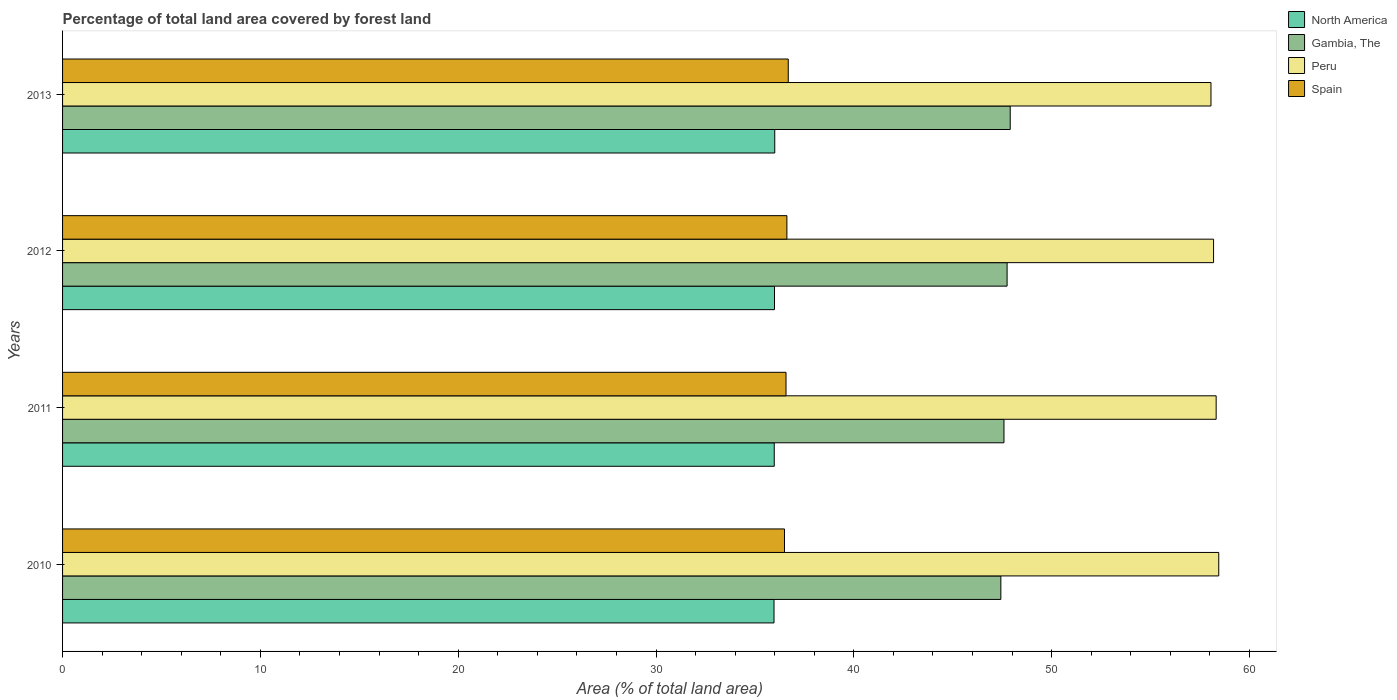Are the number of bars on each tick of the Y-axis equal?
Make the answer very short. Yes. How many bars are there on the 1st tick from the top?
Keep it short and to the point. 4. How many bars are there on the 4th tick from the bottom?
Offer a very short reply. 4. What is the percentage of forest land in Peru in 2011?
Keep it short and to the point. 58.32. Across all years, what is the maximum percentage of forest land in Spain?
Provide a succinct answer. 36.68. Across all years, what is the minimum percentage of forest land in North America?
Keep it short and to the point. 35.96. In which year was the percentage of forest land in Spain maximum?
Offer a very short reply. 2013. In which year was the percentage of forest land in Spain minimum?
Your answer should be compact. 2010. What is the total percentage of forest land in Peru in the graph?
Offer a terse response. 233. What is the difference between the percentage of forest land in Spain in 2010 and that in 2012?
Offer a very short reply. -0.12. What is the difference between the percentage of forest land in Gambia, The in 2013 and the percentage of forest land in North America in 2012?
Provide a succinct answer. 11.92. What is the average percentage of forest land in Spain per year?
Your answer should be very brief. 36.59. In the year 2012, what is the difference between the percentage of forest land in Peru and percentage of forest land in Spain?
Offer a terse response. 21.57. What is the ratio of the percentage of forest land in North America in 2010 to that in 2011?
Give a very brief answer. 1. Is the percentage of forest land in Spain in 2011 less than that in 2012?
Provide a succinct answer. Yes. Is the difference between the percentage of forest land in Peru in 2010 and 2013 greater than the difference between the percentage of forest land in Spain in 2010 and 2013?
Offer a terse response. Yes. What is the difference between the highest and the second highest percentage of forest land in Spain?
Provide a succinct answer. 0.07. What is the difference between the highest and the lowest percentage of forest land in Spain?
Keep it short and to the point. 0.19. What does the 3rd bar from the top in 2010 represents?
Your answer should be compact. Gambia, The. Are all the bars in the graph horizontal?
Your answer should be very brief. Yes. How many years are there in the graph?
Your response must be concise. 4. What is the difference between two consecutive major ticks on the X-axis?
Provide a short and direct response. 10. Does the graph contain any zero values?
Provide a short and direct response. No. Does the graph contain grids?
Keep it short and to the point. No. How are the legend labels stacked?
Offer a very short reply. Vertical. What is the title of the graph?
Your response must be concise. Percentage of total land area covered by forest land. What is the label or title of the X-axis?
Your answer should be compact. Area (% of total land area). What is the label or title of the Y-axis?
Make the answer very short. Years. What is the Area (% of total land area) of North America in 2010?
Give a very brief answer. 35.96. What is the Area (% of total land area) of Gambia, The in 2010?
Your answer should be compact. 47.43. What is the Area (% of total land area) of Peru in 2010?
Your answer should be very brief. 58.45. What is the Area (% of total land area) in Spain in 2010?
Give a very brief answer. 36.49. What is the Area (% of total land area) in North America in 2011?
Your answer should be compact. 35.98. What is the Area (% of total land area) in Gambia, The in 2011?
Make the answer very short. 47.59. What is the Area (% of total land area) of Peru in 2011?
Offer a very short reply. 58.32. What is the Area (% of total land area) in Spain in 2011?
Your answer should be very brief. 36.57. What is the Area (% of total land area) in North America in 2012?
Keep it short and to the point. 35.99. What is the Area (% of total land area) in Gambia, The in 2012?
Give a very brief answer. 47.75. What is the Area (% of total land area) in Peru in 2012?
Offer a very short reply. 58.18. What is the Area (% of total land area) in Spain in 2012?
Keep it short and to the point. 36.62. What is the Area (% of total land area) in North America in 2013?
Your response must be concise. 36. What is the Area (% of total land area) of Gambia, The in 2013?
Make the answer very short. 47.91. What is the Area (% of total land area) of Peru in 2013?
Provide a short and direct response. 58.05. What is the Area (% of total land area) in Spain in 2013?
Provide a short and direct response. 36.68. Across all years, what is the maximum Area (% of total land area) in North America?
Provide a succinct answer. 36. Across all years, what is the maximum Area (% of total land area) of Gambia, The?
Offer a very short reply. 47.91. Across all years, what is the maximum Area (% of total land area) of Peru?
Your response must be concise. 58.45. Across all years, what is the maximum Area (% of total land area) of Spain?
Your answer should be compact. 36.68. Across all years, what is the minimum Area (% of total land area) of North America?
Make the answer very short. 35.96. Across all years, what is the minimum Area (% of total land area) of Gambia, The?
Ensure brevity in your answer.  47.43. Across all years, what is the minimum Area (% of total land area) in Peru?
Your response must be concise. 58.05. Across all years, what is the minimum Area (% of total land area) in Spain?
Provide a succinct answer. 36.49. What is the total Area (% of total land area) in North America in the graph?
Make the answer very short. 143.93. What is the total Area (% of total land area) in Gambia, The in the graph?
Give a very brief answer. 190.67. What is the total Area (% of total land area) of Peru in the graph?
Provide a succinct answer. 233. What is the total Area (% of total land area) in Spain in the graph?
Keep it short and to the point. 146.36. What is the difference between the Area (% of total land area) of North America in 2010 and that in 2011?
Provide a succinct answer. -0.01. What is the difference between the Area (% of total land area) of Gambia, The in 2010 and that in 2011?
Your answer should be compact. -0.16. What is the difference between the Area (% of total land area) of Peru in 2010 and that in 2011?
Your answer should be compact. 0.13. What is the difference between the Area (% of total land area) in Spain in 2010 and that in 2011?
Your response must be concise. -0.08. What is the difference between the Area (% of total land area) in North America in 2010 and that in 2012?
Your answer should be very brief. -0.03. What is the difference between the Area (% of total land area) of Gambia, The in 2010 and that in 2012?
Offer a very short reply. -0.32. What is the difference between the Area (% of total land area) in Peru in 2010 and that in 2012?
Give a very brief answer. 0.26. What is the difference between the Area (% of total land area) in Spain in 2010 and that in 2012?
Your response must be concise. -0.12. What is the difference between the Area (% of total land area) in North America in 2010 and that in 2013?
Offer a terse response. -0.04. What is the difference between the Area (% of total land area) of Gambia, The in 2010 and that in 2013?
Your response must be concise. -0.47. What is the difference between the Area (% of total land area) of Peru in 2010 and that in 2013?
Your answer should be compact. 0.39. What is the difference between the Area (% of total land area) in Spain in 2010 and that in 2013?
Your response must be concise. -0.19. What is the difference between the Area (% of total land area) in North America in 2011 and that in 2012?
Provide a short and direct response. -0.01. What is the difference between the Area (% of total land area) in Gambia, The in 2011 and that in 2012?
Keep it short and to the point. -0.16. What is the difference between the Area (% of total land area) in Peru in 2011 and that in 2012?
Keep it short and to the point. 0.13. What is the difference between the Area (% of total land area) of Spain in 2011 and that in 2012?
Provide a short and direct response. -0.04. What is the difference between the Area (% of total land area) of North America in 2011 and that in 2013?
Make the answer very short. -0.03. What is the difference between the Area (% of total land area) of Gambia, The in 2011 and that in 2013?
Offer a very short reply. -0.32. What is the difference between the Area (% of total land area) of Peru in 2011 and that in 2013?
Offer a terse response. 0.26. What is the difference between the Area (% of total land area) in Spain in 2011 and that in 2013?
Offer a very short reply. -0.11. What is the difference between the Area (% of total land area) in North America in 2012 and that in 2013?
Give a very brief answer. -0.01. What is the difference between the Area (% of total land area) of Gambia, The in 2012 and that in 2013?
Provide a short and direct response. -0.16. What is the difference between the Area (% of total land area) in Peru in 2012 and that in 2013?
Give a very brief answer. 0.13. What is the difference between the Area (% of total land area) of Spain in 2012 and that in 2013?
Your response must be concise. -0.07. What is the difference between the Area (% of total land area) in North America in 2010 and the Area (% of total land area) in Gambia, The in 2011?
Your answer should be compact. -11.62. What is the difference between the Area (% of total land area) in North America in 2010 and the Area (% of total land area) in Peru in 2011?
Give a very brief answer. -22.35. What is the difference between the Area (% of total land area) in North America in 2010 and the Area (% of total land area) in Spain in 2011?
Give a very brief answer. -0.61. What is the difference between the Area (% of total land area) of Gambia, The in 2010 and the Area (% of total land area) of Peru in 2011?
Ensure brevity in your answer.  -10.88. What is the difference between the Area (% of total land area) in Gambia, The in 2010 and the Area (% of total land area) in Spain in 2011?
Offer a terse response. 10.86. What is the difference between the Area (% of total land area) of Peru in 2010 and the Area (% of total land area) of Spain in 2011?
Keep it short and to the point. 21.87. What is the difference between the Area (% of total land area) of North America in 2010 and the Area (% of total land area) of Gambia, The in 2012?
Your answer should be compact. -11.78. What is the difference between the Area (% of total land area) of North America in 2010 and the Area (% of total land area) of Peru in 2012?
Give a very brief answer. -22.22. What is the difference between the Area (% of total land area) of North America in 2010 and the Area (% of total land area) of Spain in 2012?
Keep it short and to the point. -0.65. What is the difference between the Area (% of total land area) in Gambia, The in 2010 and the Area (% of total land area) in Peru in 2012?
Provide a succinct answer. -10.75. What is the difference between the Area (% of total land area) in Gambia, The in 2010 and the Area (% of total land area) in Spain in 2012?
Provide a succinct answer. 10.82. What is the difference between the Area (% of total land area) in Peru in 2010 and the Area (% of total land area) in Spain in 2012?
Give a very brief answer. 21.83. What is the difference between the Area (% of total land area) in North America in 2010 and the Area (% of total land area) in Gambia, The in 2013?
Offer a terse response. -11.94. What is the difference between the Area (% of total land area) of North America in 2010 and the Area (% of total land area) of Peru in 2013?
Your response must be concise. -22.09. What is the difference between the Area (% of total land area) in North America in 2010 and the Area (% of total land area) in Spain in 2013?
Make the answer very short. -0.72. What is the difference between the Area (% of total land area) of Gambia, The in 2010 and the Area (% of total land area) of Peru in 2013?
Keep it short and to the point. -10.62. What is the difference between the Area (% of total land area) in Gambia, The in 2010 and the Area (% of total land area) in Spain in 2013?
Make the answer very short. 10.75. What is the difference between the Area (% of total land area) of Peru in 2010 and the Area (% of total land area) of Spain in 2013?
Give a very brief answer. 21.76. What is the difference between the Area (% of total land area) of North America in 2011 and the Area (% of total land area) of Gambia, The in 2012?
Provide a short and direct response. -11.77. What is the difference between the Area (% of total land area) of North America in 2011 and the Area (% of total land area) of Peru in 2012?
Offer a terse response. -22.21. What is the difference between the Area (% of total land area) in North America in 2011 and the Area (% of total land area) in Spain in 2012?
Provide a succinct answer. -0.64. What is the difference between the Area (% of total land area) of Gambia, The in 2011 and the Area (% of total land area) of Peru in 2012?
Keep it short and to the point. -10.6. What is the difference between the Area (% of total land area) of Gambia, The in 2011 and the Area (% of total land area) of Spain in 2012?
Offer a terse response. 10.97. What is the difference between the Area (% of total land area) of Peru in 2011 and the Area (% of total land area) of Spain in 2012?
Provide a short and direct response. 21.7. What is the difference between the Area (% of total land area) of North America in 2011 and the Area (% of total land area) of Gambia, The in 2013?
Provide a succinct answer. -11.93. What is the difference between the Area (% of total land area) in North America in 2011 and the Area (% of total land area) in Peru in 2013?
Provide a succinct answer. -22.08. What is the difference between the Area (% of total land area) in North America in 2011 and the Area (% of total land area) in Spain in 2013?
Offer a very short reply. -0.71. What is the difference between the Area (% of total land area) in Gambia, The in 2011 and the Area (% of total land area) in Peru in 2013?
Your answer should be very brief. -10.46. What is the difference between the Area (% of total land area) of Gambia, The in 2011 and the Area (% of total land area) of Spain in 2013?
Offer a terse response. 10.91. What is the difference between the Area (% of total land area) of Peru in 2011 and the Area (% of total land area) of Spain in 2013?
Keep it short and to the point. 21.63. What is the difference between the Area (% of total land area) of North America in 2012 and the Area (% of total land area) of Gambia, The in 2013?
Keep it short and to the point. -11.92. What is the difference between the Area (% of total land area) in North America in 2012 and the Area (% of total land area) in Peru in 2013?
Offer a very short reply. -22.06. What is the difference between the Area (% of total land area) in North America in 2012 and the Area (% of total land area) in Spain in 2013?
Ensure brevity in your answer.  -0.69. What is the difference between the Area (% of total land area) of Gambia, The in 2012 and the Area (% of total land area) of Peru in 2013?
Provide a short and direct response. -10.31. What is the difference between the Area (% of total land area) of Gambia, The in 2012 and the Area (% of total land area) of Spain in 2013?
Your answer should be very brief. 11.06. What is the difference between the Area (% of total land area) in Peru in 2012 and the Area (% of total land area) in Spain in 2013?
Offer a terse response. 21.5. What is the average Area (% of total land area) of North America per year?
Ensure brevity in your answer.  35.98. What is the average Area (% of total land area) of Gambia, The per year?
Your answer should be very brief. 47.67. What is the average Area (% of total land area) in Peru per year?
Give a very brief answer. 58.25. What is the average Area (% of total land area) of Spain per year?
Provide a short and direct response. 36.59. In the year 2010, what is the difference between the Area (% of total land area) in North America and Area (% of total land area) in Gambia, The?
Provide a short and direct response. -11.47. In the year 2010, what is the difference between the Area (% of total land area) in North America and Area (% of total land area) in Peru?
Give a very brief answer. -22.48. In the year 2010, what is the difference between the Area (% of total land area) in North America and Area (% of total land area) in Spain?
Offer a terse response. -0.53. In the year 2010, what is the difference between the Area (% of total land area) of Gambia, The and Area (% of total land area) of Peru?
Keep it short and to the point. -11.02. In the year 2010, what is the difference between the Area (% of total land area) in Gambia, The and Area (% of total land area) in Spain?
Offer a terse response. 10.94. In the year 2010, what is the difference between the Area (% of total land area) of Peru and Area (% of total land area) of Spain?
Offer a very short reply. 21.95. In the year 2011, what is the difference between the Area (% of total land area) of North America and Area (% of total land area) of Gambia, The?
Offer a very short reply. -11.61. In the year 2011, what is the difference between the Area (% of total land area) of North America and Area (% of total land area) of Peru?
Give a very brief answer. -22.34. In the year 2011, what is the difference between the Area (% of total land area) of North America and Area (% of total land area) of Spain?
Offer a very short reply. -0.59. In the year 2011, what is the difference between the Area (% of total land area) of Gambia, The and Area (% of total land area) of Peru?
Keep it short and to the point. -10.73. In the year 2011, what is the difference between the Area (% of total land area) of Gambia, The and Area (% of total land area) of Spain?
Offer a terse response. 11.02. In the year 2011, what is the difference between the Area (% of total land area) of Peru and Area (% of total land area) of Spain?
Your response must be concise. 21.74. In the year 2012, what is the difference between the Area (% of total land area) in North America and Area (% of total land area) in Gambia, The?
Your answer should be compact. -11.76. In the year 2012, what is the difference between the Area (% of total land area) in North America and Area (% of total land area) in Peru?
Offer a very short reply. -22.19. In the year 2012, what is the difference between the Area (% of total land area) of North America and Area (% of total land area) of Spain?
Your response must be concise. -0.63. In the year 2012, what is the difference between the Area (% of total land area) of Gambia, The and Area (% of total land area) of Peru?
Your response must be concise. -10.44. In the year 2012, what is the difference between the Area (% of total land area) in Gambia, The and Area (% of total land area) in Spain?
Your response must be concise. 11.13. In the year 2012, what is the difference between the Area (% of total land area) in Peru and Area (% of total land area) in Spain?
Ensure brevity in your answer.  21.57. In the year 2013, what is the difference between the Area (% of total land area) of North America and Area (% of total land area) of Gambia, The?
Offer a very short reply. -11.9. In the year 2013, what is the difference between the Area (% of total land area) of North America and Area (% of total land area) of Peru?
Keep it short and to the point. -22.05. In the year 2013, what is the difference between the Area (% of total land area) of North America and Area (% of total land area) of Spain?
Provide a succinct answer. -0.68. In the year 2013, what is the difference between the Area (% of total land area) of Gambia, The and Area (% of total land area) of Peru?
Offer a very short reply. -10.15. In the year 2013, what is the difference between the Area (% of total land area) of Gambia, The and Area (% of total land area) of Spain?
Make the answer very short. 11.22. In the year 2013, what is the difference between the Area (% of total land area) of Peru and Area (% of total land area) of Spain?
Offer a terse response. 21.37. What is the ratio of the Area (% of total land area) in Gambia, The in 2010 to that in 2011?
Ensure brevity in your answer.  1. What is the ratio of the Area (% of total land area) of Peru in 2010 to that in 2011?
Provide a succinct answer. 1. What is the ratio of the Area (% of total land area) in North America in 2010 to that in 2012?
Give a very brief answer. 1. What is the ratio of the Area (% of total land area) of Gambia, The in 2010 to that in 2012?
Keep it short and to the point. 0.99. What is the ratio of the Area (% of total land area) in Spain in 2010 to that in 2012?
Keep it short and to the point. 1. What is the ratio of the Area (% of total land area) in North America in 2010 to that in 2013?
Provide a succinct answer. 1. What is the ratio of the Area (% of total land area) of Gambia, The in 2010 to that in 2013?
Make the answer very short. 0.99. What is the ratio of the Area (% of total land area) in Peru in 2010 to that in 2013?
Give a very brief answer. 1.01. What is the ratio of the Area (% of total land area) in Spain in 2010 to that in 2013?
Your answer should be very brief. 0.99. What is the ratio of the Area (% of total land area) in North America in 2011 to that in 2012?
Give a very brief answer. 1. What is the ratio of the Area (% of total land area) in Peru in 2011 to that in 2012?
Keep it short and to the point. 1. What is the ratio of the Area (% of total land area) of North America in 2011 to that in 2013?
Ensure brevity in your answer.  1. What is the ratio of the Area (% of total land area) of Spain in 2011 to that in 2013?
Your answer should be very brief. 1. What is the ratio of the Area (% of total land area) of North America in 2012 to that in 2013?
Give a very brief answer. 1. What is the ratio of the Area (% of total land area) of Peru in 2012 to that in 2013?
Provide a succinct answer. 1. What is the difference between the highest and the second highest Area (% of total land area) in North America?
Offer a very short reply. 0.01. What is the difference between the highest and the second highest Area (% of total land area) in Gambia, The?
Your response must be concise. 0.16. What is the difference between the highest and the second highest Area (% of total land area) in Peru?
Offer a very short reply. 0.13. What is the difference between the highest and the second highest Area (% of total land area) of Spain?
Your answer should be compact. 0.07. What is the difference between the highest and the lowest Area (% of total land area) of North America?
Offer a very short reply. 0.04. What is the difference between the highest and the lowest Area (% of total land area) of Gambia, The?
Offer a very short reply. 0.47. What is the difference between the highest and the lowest Area (% of total land area) in Peru?
Provide a succinct answer. 0.39. What is the difference between the highest and the lowest Area (% of total land area) in Spain?
Your response must be concise. 0.19. 